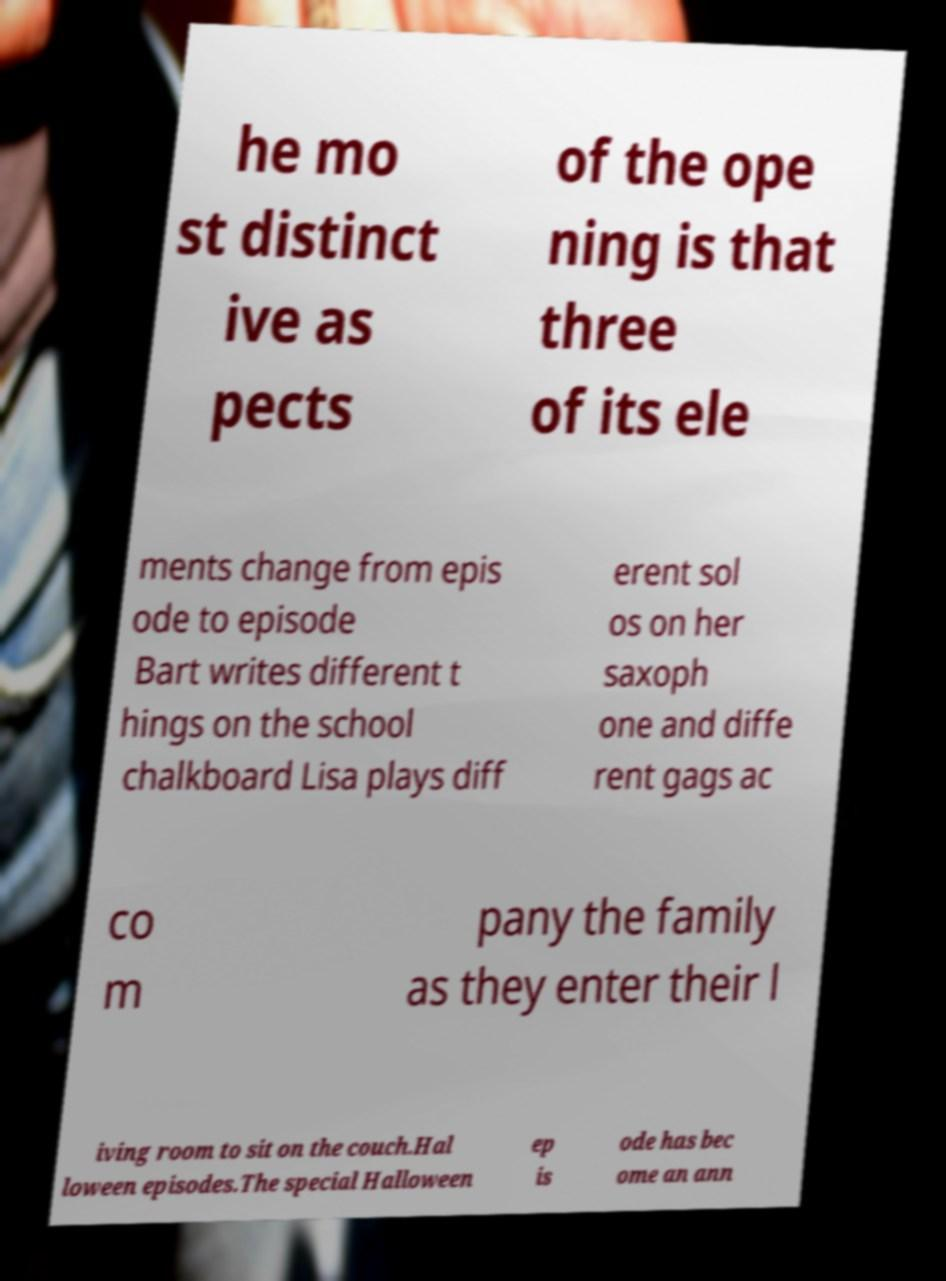Could you assist in decoding the text presented in this image and type it out clearly? he mo st distinct ive as pects of the ope ning is that three of its ele ments change from epis ode to episode Bart writes different t hings on the school chalkboard Lisa plays diff erent sol os on her saxoph one and diffe rent gags ac co m pany the family as they enter their l iving room to sit on the couch.Hal loween episodes.The special Halloween ep is ode has bec ome an ann 